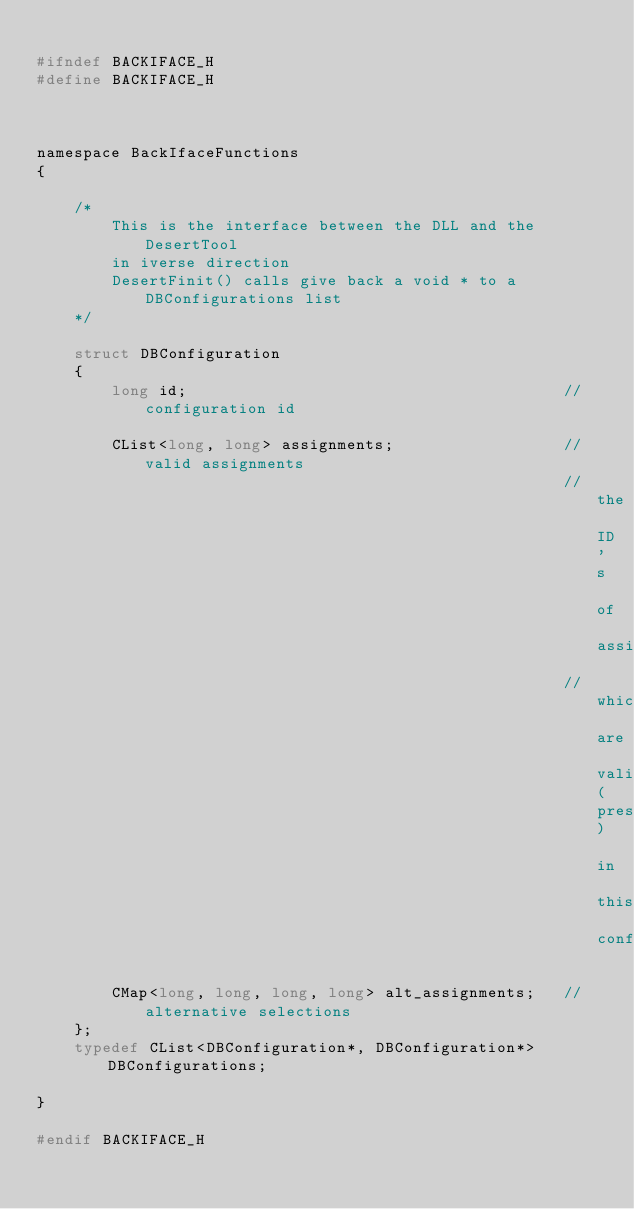<code> <loc_0><loc_0><loc_500><loc_500><_C_>
#ifndef BACKIFACE_H
#define BACKIFACE_H



namespace BackIfaceFunctions
{

	/*
		This is the interface between the DLL and the DesertTool
		in iverse direction
		DesertFinit() calls give back a void * to a DBConfigurations list
	*/

	struct DBConfiguration
	{
		long id;										//configuration id
		
		CList<long, long> assignments;					//valid assignments
														//the ID's of assignments
														//which are valid(present) in this configuration

		CMap<long, long, long, long> alt_assignments;   //alternative selections
	};
	typedef CList<DBConfiguration*, DBConfiguration*> DBConfigurations;

}

#endif BACKIFACE_H



</code> 